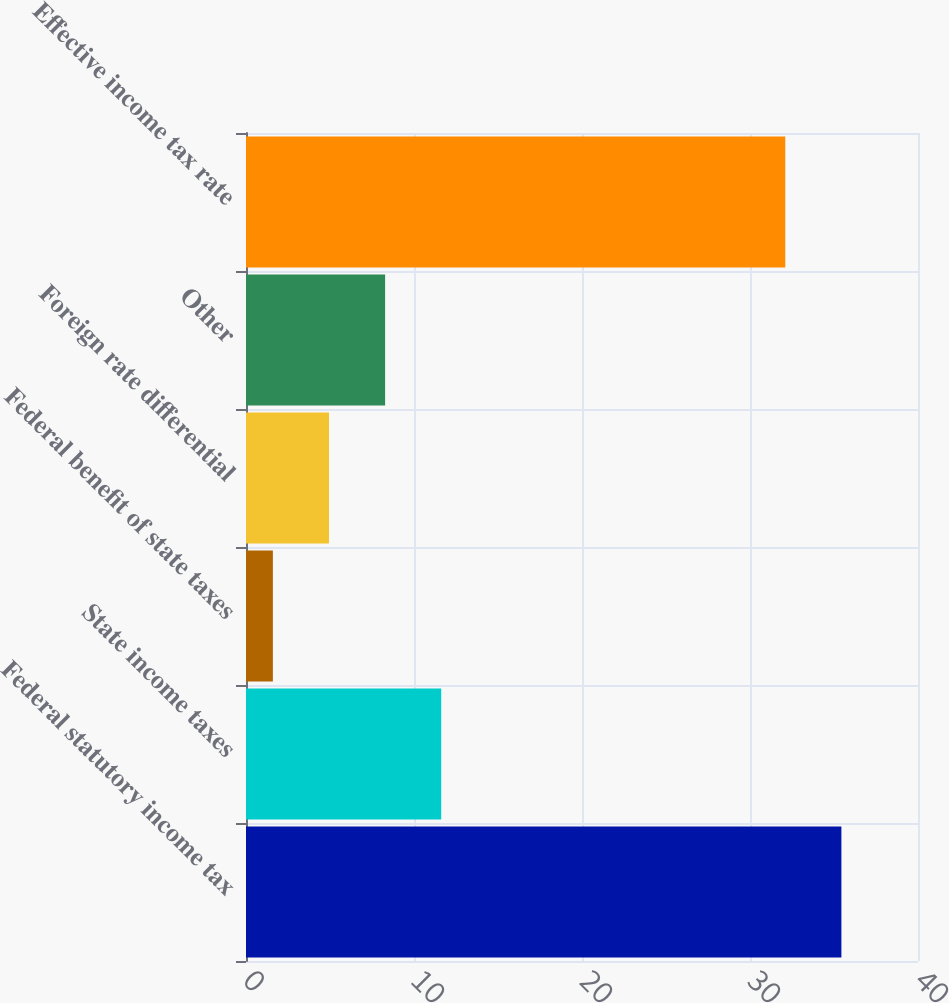Convert chart to OTSL. <chart><loc_0><loc_0><loc_500><loc_500><bar_chart><fcel>Federal statutory income tax<fcel>State income taxes<fcel>Federal benefit of state taxes<fcel>Foreign rate differential<fcel>Other<fcel>Effective income tax rate<nl><fcel>35.44<fcel>11.62<fcel>1.6<fcel>4.94<fcel>8.28<fcel>32.1<nl></chart> 